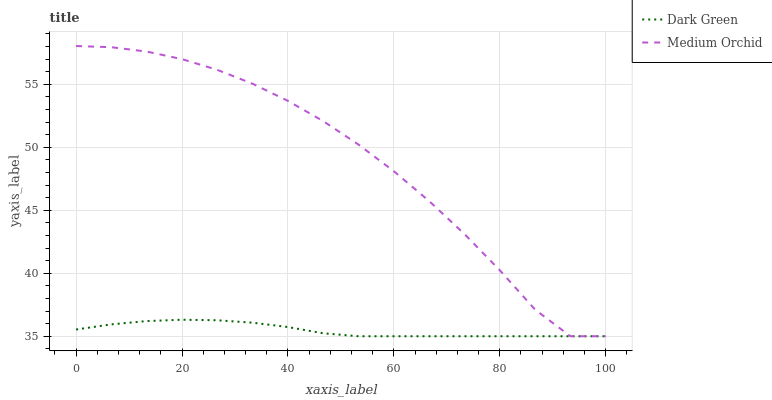Does Dark Green have the minimum area under the curve?
Answer yes or no. Yes. Does Medium Orchid have the maximum area under the curve?
Answer yes or no. Yes. Does Dark Green have the maximum area under the curve?
Answer yes or no. No. Is Dark Green the smoothest?
Answer yes or no. Yes. Is Medium Orchid the roughest?
Answer yes or no. Yes. Is Dark Green the roughest?
Answer yes or no. No. Does Medium Orchid have the lowest value?
Answer yes or no. Yes. Does Medium Orchid have the highest value?
Answer yes or no. Yes. Does Dark Green have the highest value?
Answer yes or no. No. Does Medium Orchid intersect Dark Green?
Answer yes or no. Yes. Is Medium Orchid less than Dark Green?
Answer yes or no. No. Is Medium Orchid greater than Dark Green?
Answer yes or no. No. 